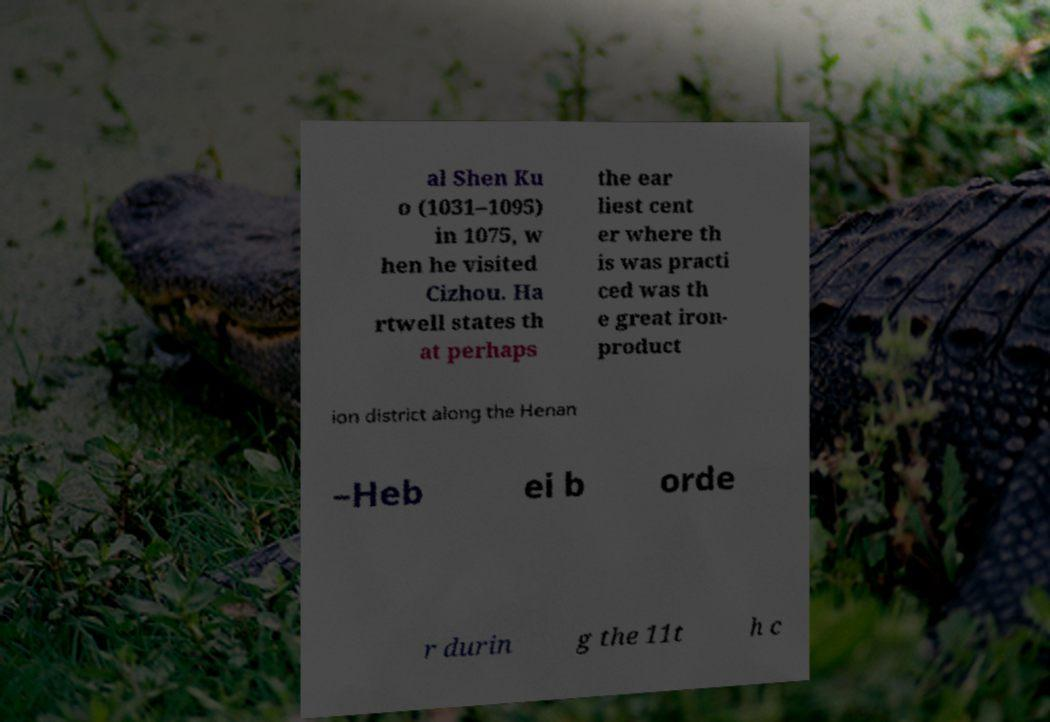Could you assist in decoding the text presented in this image and type it out clearly? al Shen Ku o (1031–1095) in 1075, w hen he visited Cizhou. Ha rtwell states th at perhaps the ear liest cent er where th is was practi ced was th e great iron- product ion district along the Henan –Heb ei b orde r durin g the 11t h c 